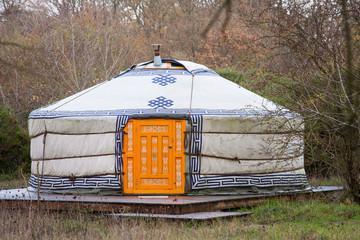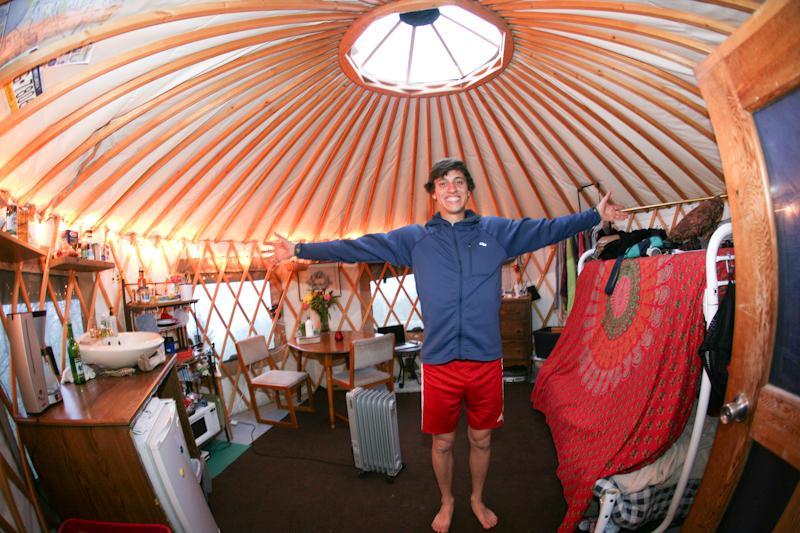The first image is the image on the left, the second image is the image on the right. Evaluate the accuracy of this statement regarding the images: "Exterior view of a tent with a red door.". Is it true? Answer yes or no. No. 